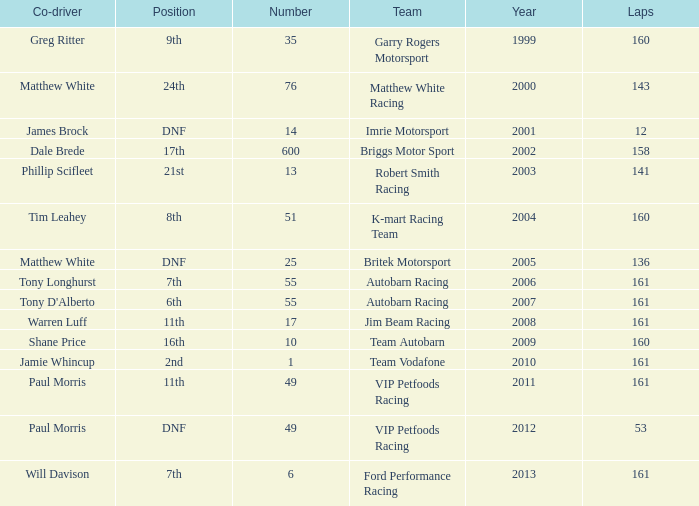What is the fewest laps for a team with a position of DNF and a number smaller than 25 before 2001? None. 